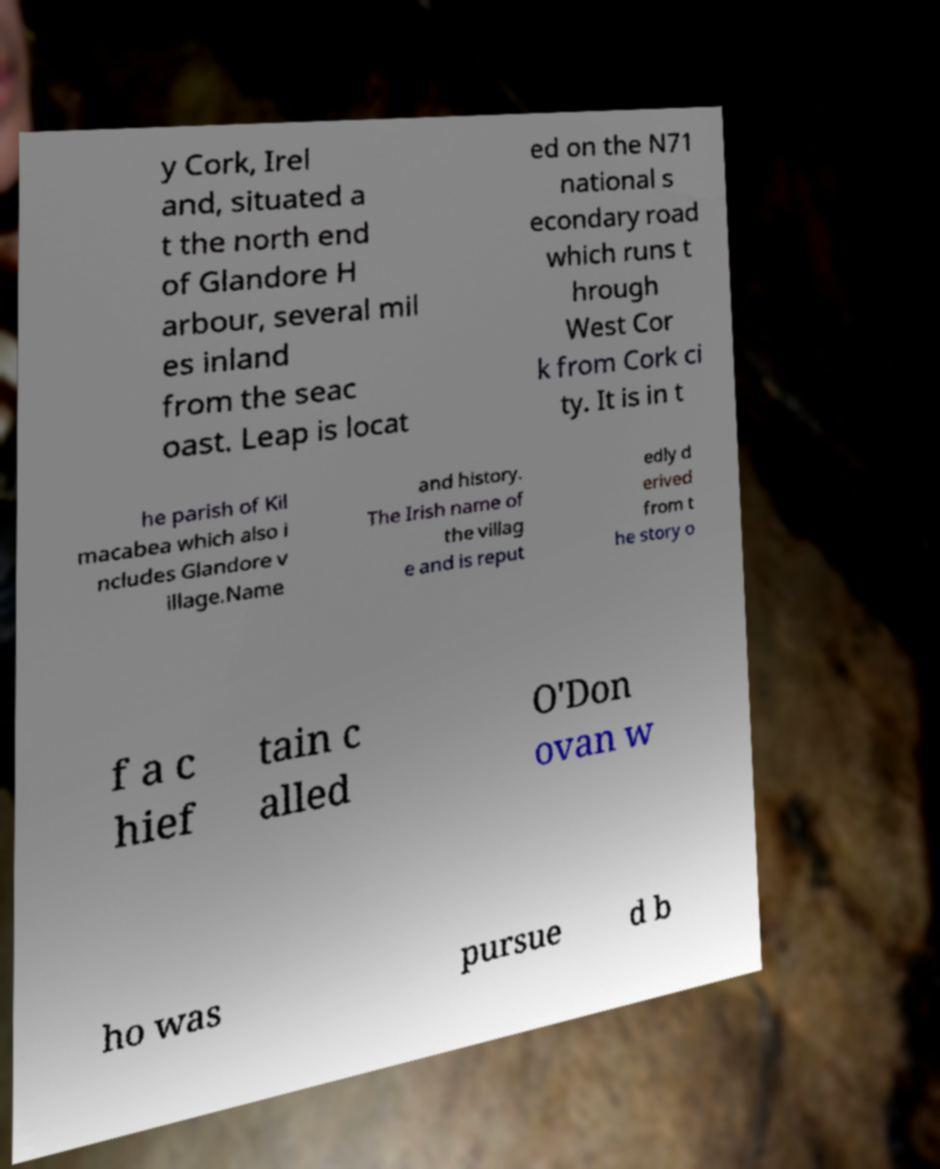Please identify and transcribe the text found in this image. y Cork, Irel and, situated a t the north end of Glandore H arbour, several mil es inland from the seac oast. Leap is locat ed on the N71 national s econdary road which runs t hrough West Cor k from Cork ci ty. It is in t he parish of Kil macabea which also i ncludes Glandore v illage.Name and history. The Irish name of the villag e and is reput edly d erived from t he story o f a c hief tain c alled O'Don ovan w ho was pursue d b 